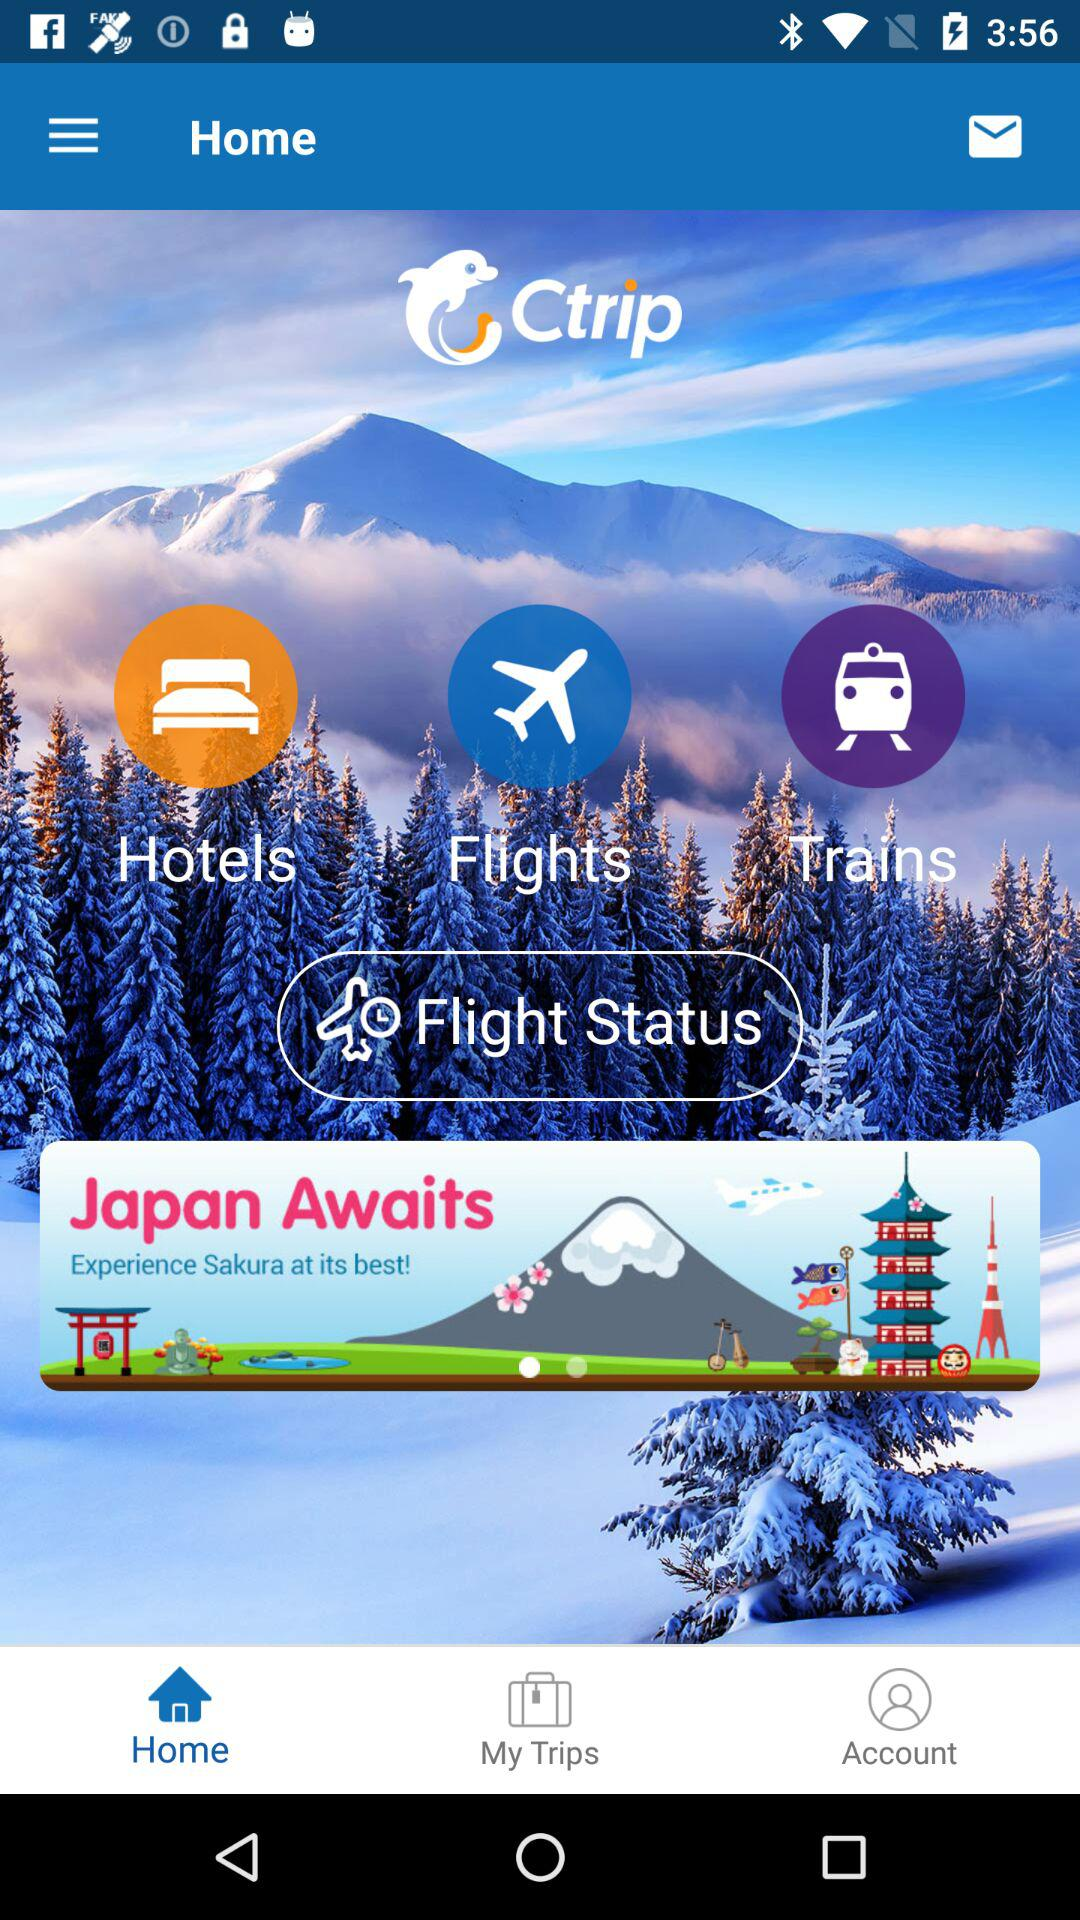Which page of the application are we currently on? You are currently on the "Home" page of the application. 